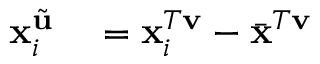<formula> <loc_0><loc_0><loc_500><loc_500>\begin{array} { r l } { x _ { i } ^ { \tilde { u } } } & = x _ { i } ^ { T v } - \bar { x } ^ { T v } } \end{array}</formula> 